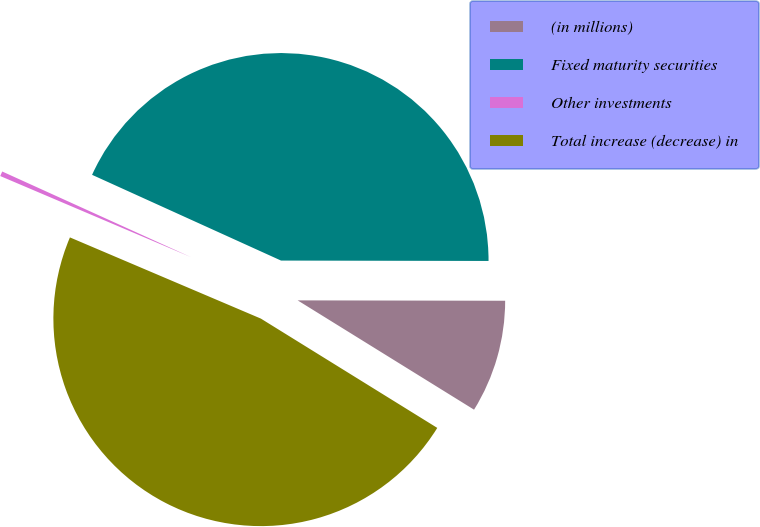Convert chart. <chart><loc_0><loc_0><loc_500><loc_500><pie_chart><fcel>(in millions)<fcel>Fixed maturity securities<fcel>Other investments<fcel>Total increase (decrease) in<nl><fcel>8.8%<fcel>43.25%<fcel>0.38%<fcel>47.57%<nl></chart> 